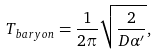Convert formula to latex. <formula><loc_0><loc_0><loc_500><loc_500>T _ { b a r y o n } = \frac { 1 } { 2 \pi } \sqrt { \frac { 2 } { D \alpha ^ { \prime } } } ,</formula> 